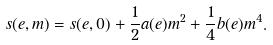<formula> <loc_0><loc_0><loc_500><loc_500>s ( e , m ) = s ( e , 0 ) + \frac { 1 } { 2 } a ( e ) m ^ { 2 } + \frac { 1 } { 4 } b ( e ) m ^ { 4 } .</formula> 